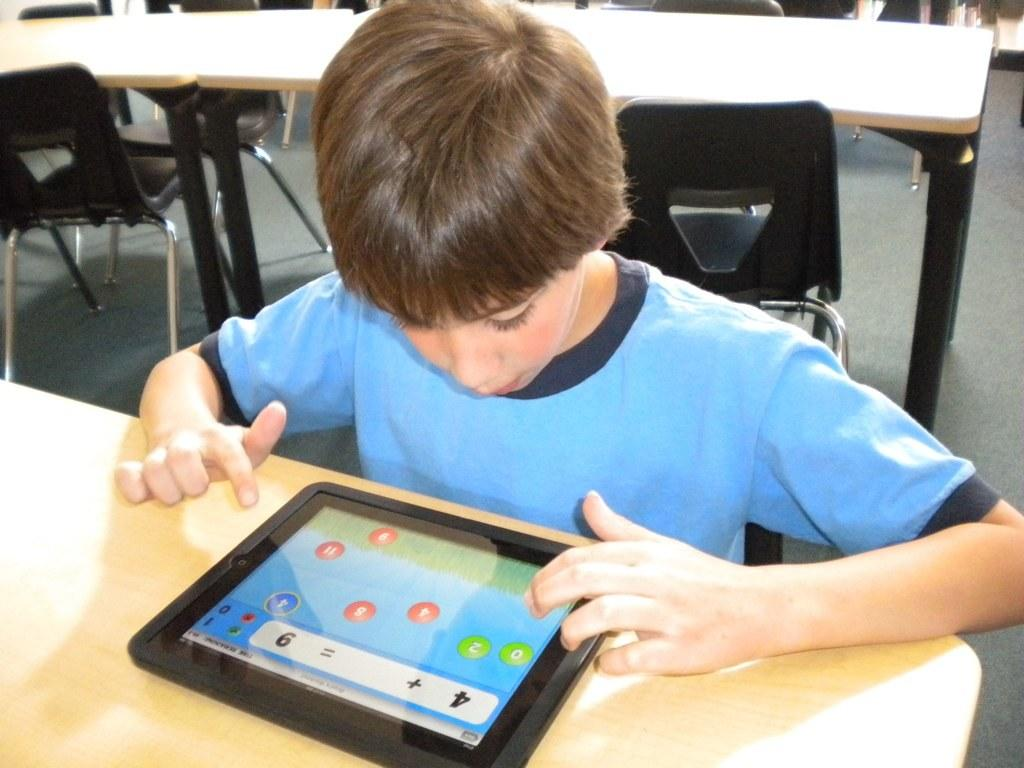Who is the main subject in the image? There is a boy in the image. What is the boy wearing? The boy is wearing a blue shirt. What is the boy looking at in the image? The boy is looking at an iPad. Where is the iPad located in the image? There is an iPad on the table. What type of furniture is visible in the image? There are tables and chairs visible in the image. What type of patch is sewn onto the boy's shirt in the image? There is no patch visible on the boy's shirt in the image. Is the boy in the image currently serving a prison sentence? There is no indication in the image that the boy is in prison or serving a prison sentence. 